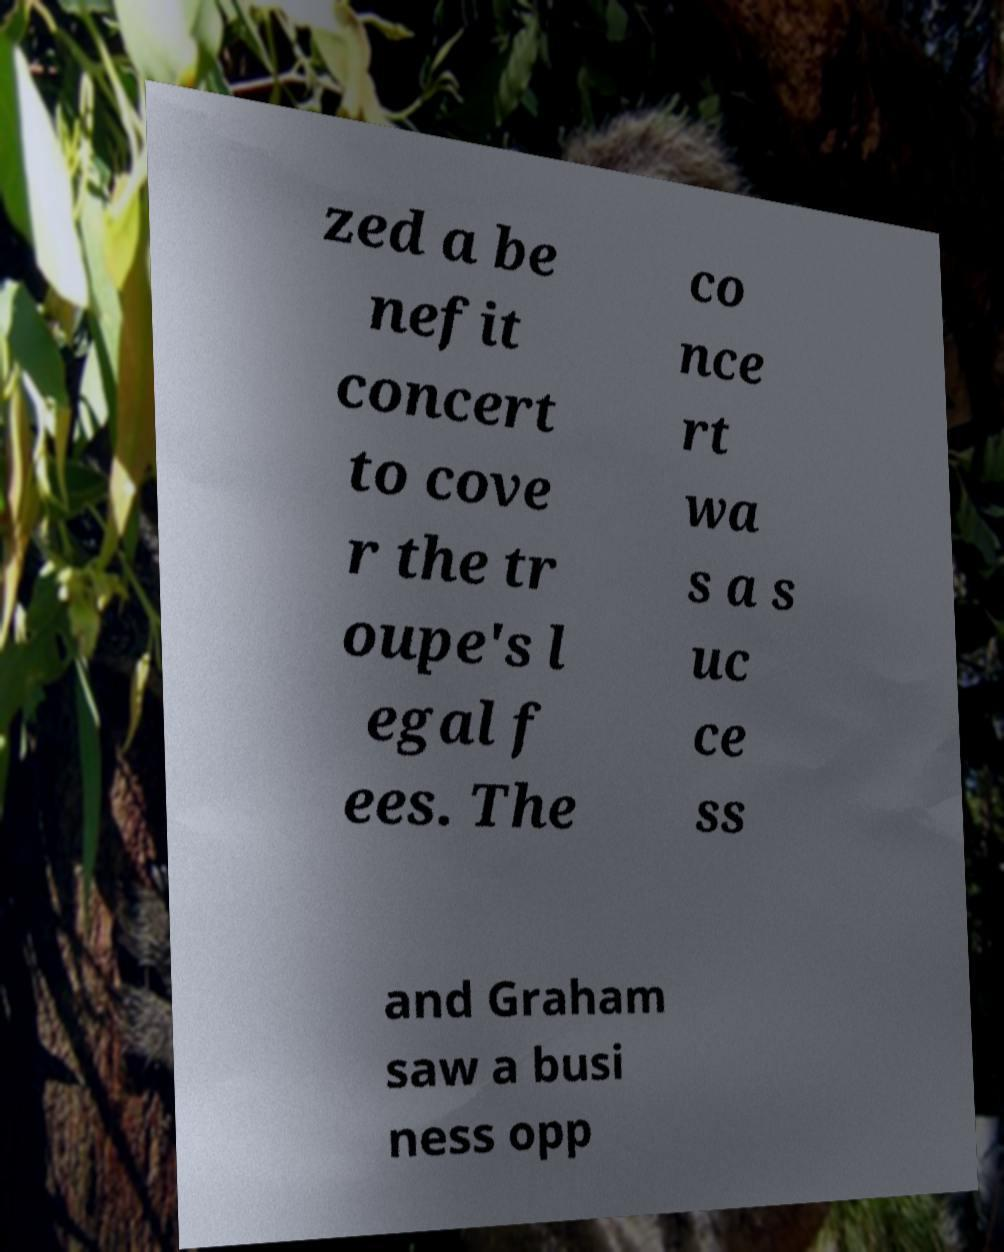I need the written content from this picture converted into text. Can you do that? zed a be nefit concert to cove r the tr oupe's l egal f ees. The co nce rt wa s a s uc ce ss and Graham saw a busi ness opp 